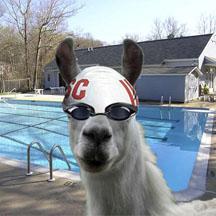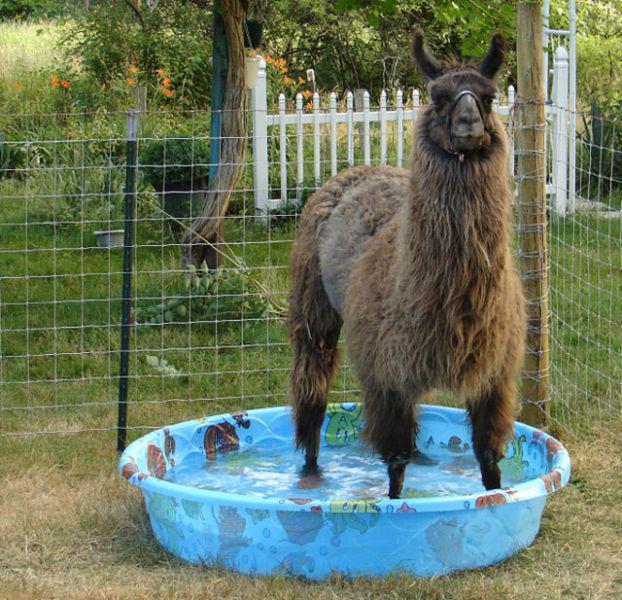The first image is the image on the left, the second image is the image on the right. For the images displayed, is the sentence "One of the images shows an alpaca in a kiddie pool and the other image shows a llama in a lake." factually correct? Answer yes or no. No. The first image is the image on the left, the second image is the image on the right. Examine the images to the left and right. Is the description "An alpaca is laying down in a small blue pool in one of the pictures." accurate? Answer yes or no. No. 